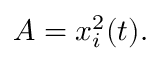<formula> <loc_0><loc_0><loc_500><loc_500>A = x _ { i } ^ { 2 } ( t ) .</formula> 